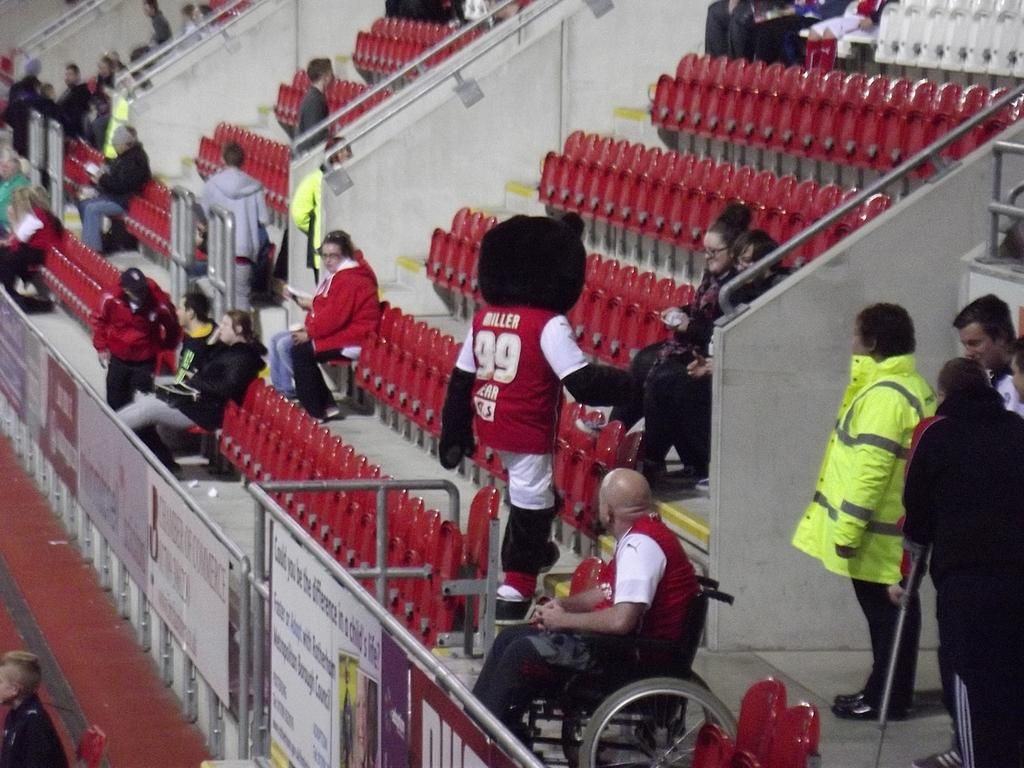How many people are in the image? There are persons in the image. What are the persons sitting on in the image? There are chairs in the image. What can be seen beneath the persons and chairs? The floor is visible in the image. What type of objects are present in the image besides the persons and chairs? There are boards in the image. What type of bread can be seen on the boards in the image? There is no bread present in the image; only persons, chairs, the floor, and boards are visible. 